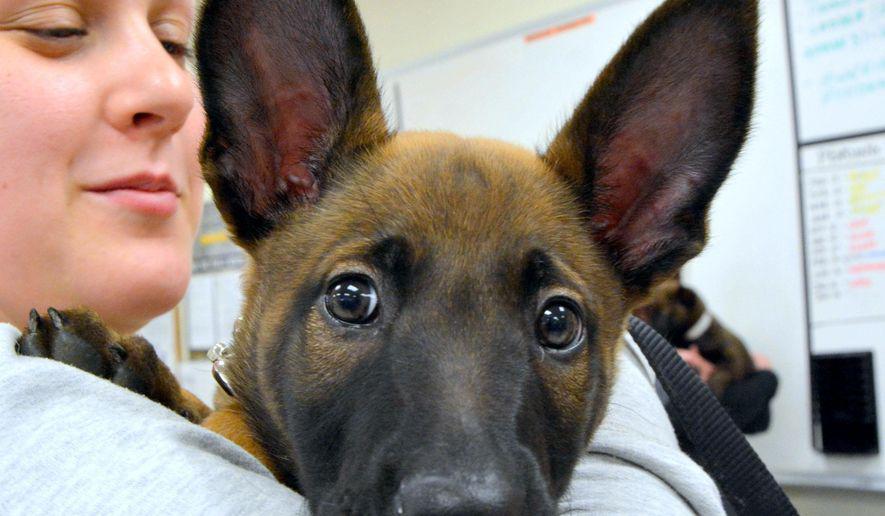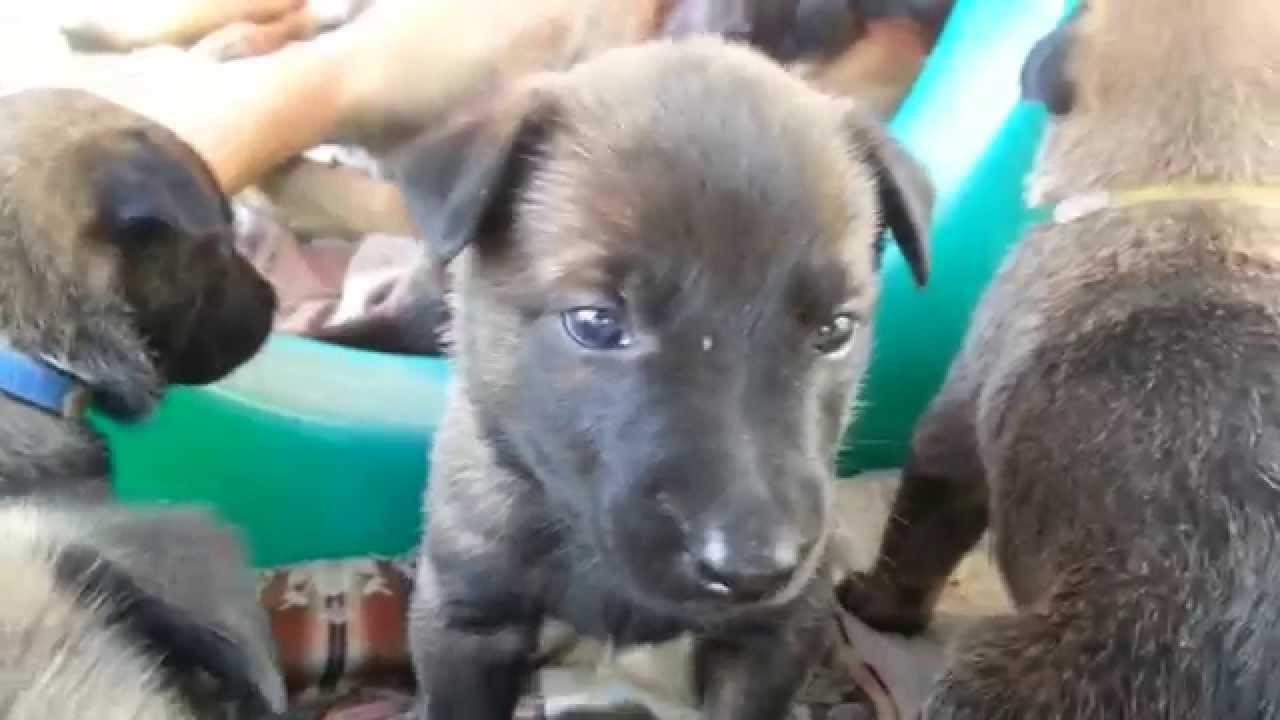The first image is the image on the left, the second image is the image on the right. Examine the images to the left and right. Is the description "A person is holding at least one dog in one image." accurate? Answer yes or no. Yes. The first image is the image on the left, the second image is the image on the right. Given the left and right images, does the statement "A person is holding at least one of the dogs in one of the images." hold true? Answer yes or no. Yes. 